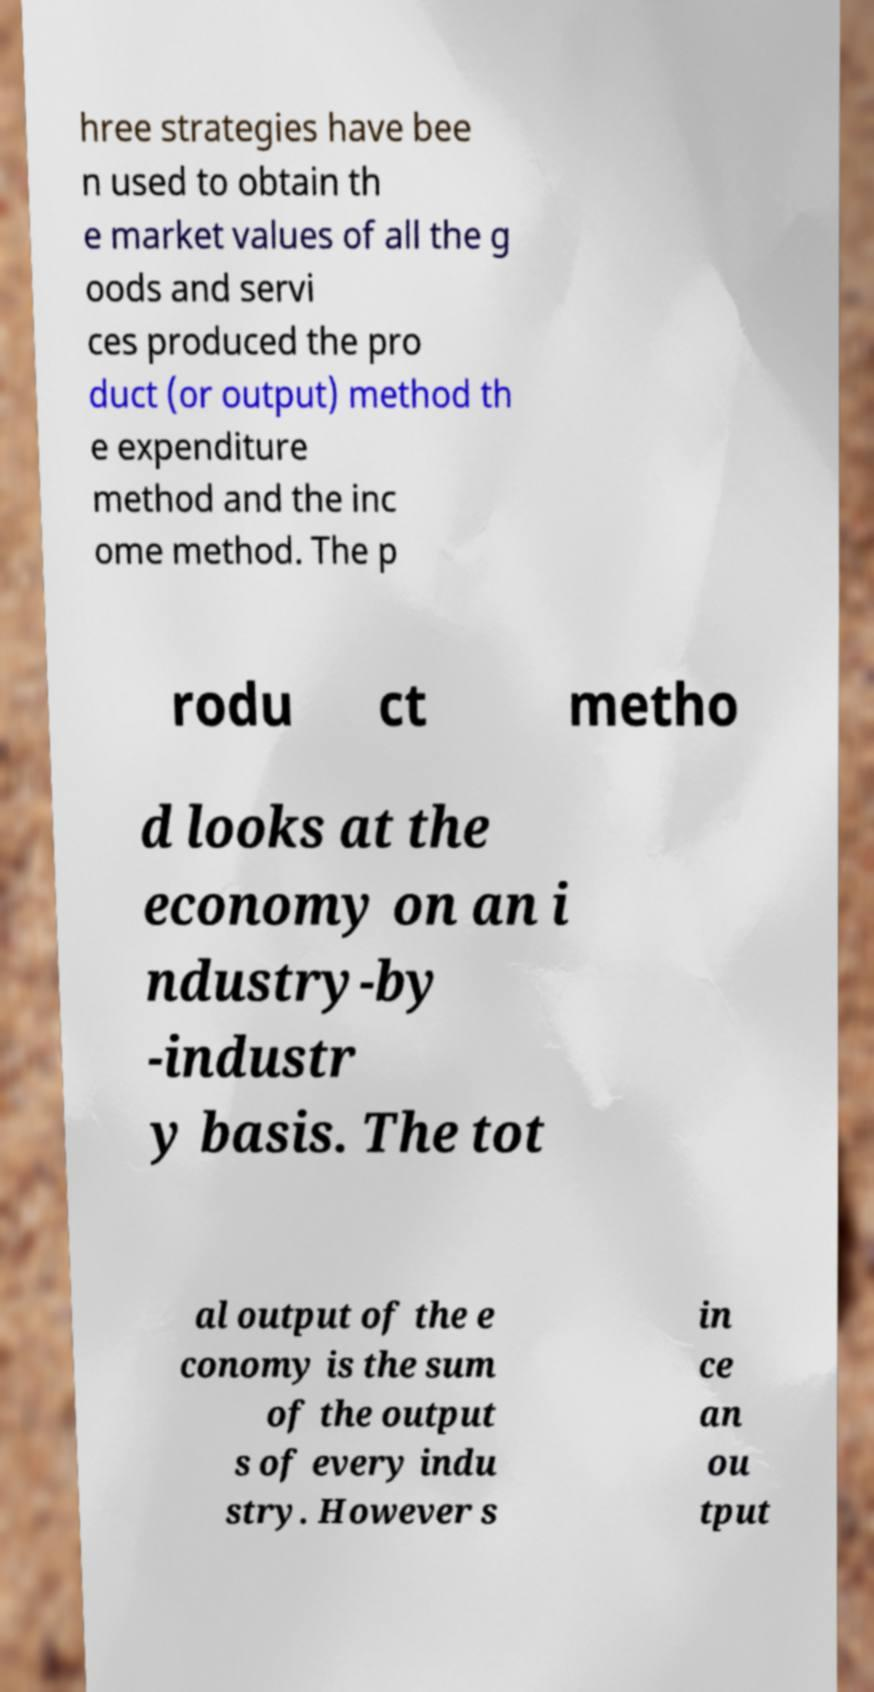Could you assist in decoding the text presented in this image and type it out clearly? hree strategies have bee n used to obtain th e market values of all the g oods and servi ces produced the pro duct (or output) method th e expenditure method and the inc ome method. The p rodu ct metho d looks at the economy on an i ndustry-by -industr y basis. The tot al output of the e conomy is the sum of the output s of every indu stry. However s in ce an ou tput 